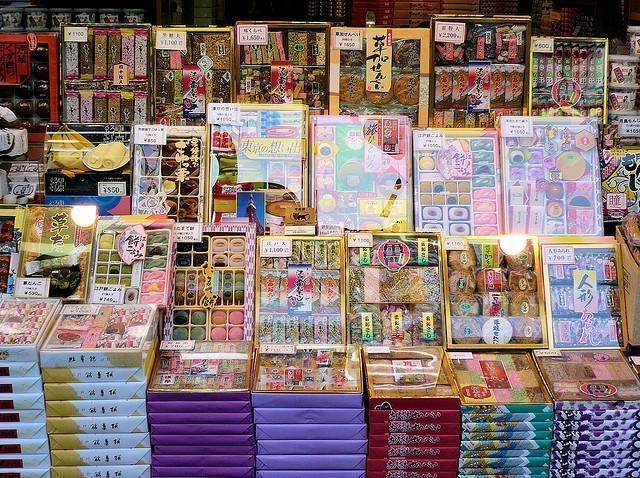Why are the boxes lined up and on display?
Answer the question by selecting the correct answer among the 4 following choices and explain your choice with a short sentence. The answer should be formatted with the following format: `Answer: choice
Rationale: rationale.`
Options: To donate, to clean, to sell, as art. Answer: to sell.
Rationale: The items have price tags on them. they are not being donated. 